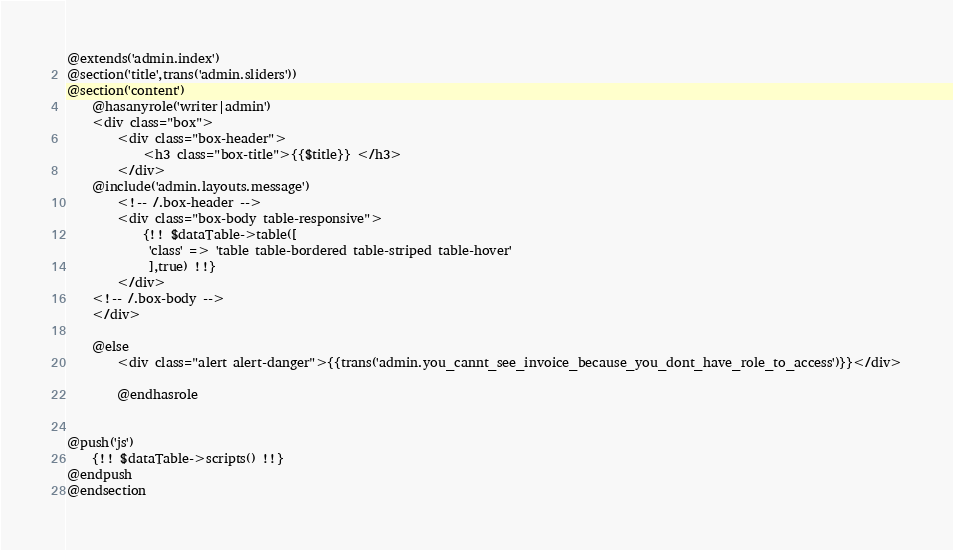<code> <loc_0><loc_0><loc_500><loc_500><_PHP_>@extends('admin.index')
@section('title',trans('admin.sliders'))
@section('content')
    @hasanyrole('writer|admin')
    <div class="box">
        <div class="box-header">
            <h3 class="box-title">{{$title}} </h3>
        </div>
    @include('admin.layouts.message')
        <!-- /.box-header -->
        <div class="box-body table-responsive">
            {!! $dataTable->table([
             'class' => 'table table-bordered table-striped table-hover'
             ],true) !!}
        </div>
    <!-- /.box-body -->
    </div>

    @else
        <div class="alert alert-danger">{{trans('admin.you_cannt_see_invoice_because_you_dont_have_role_to_access')}}</div>

        @endhasrole


@push('js')
    {!! $dataTable->scripts() !!}
@endpush
@endsection


</code> 